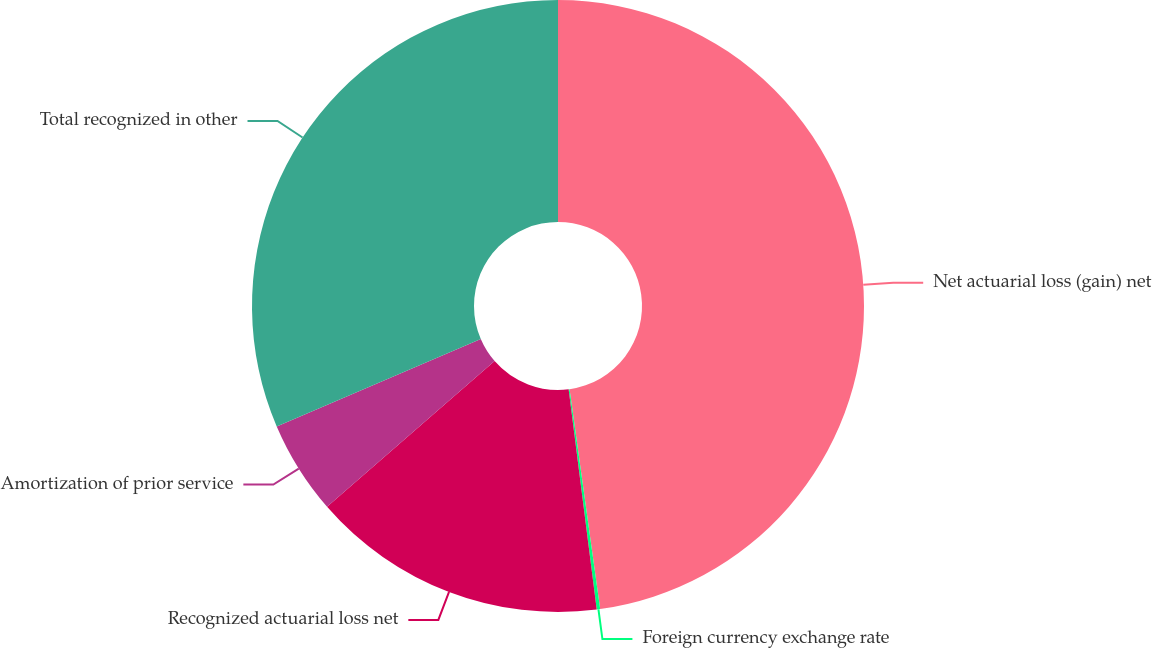<chart> <loc_0><loc_0><loc_500><loc_500><pie_chart><fcel>Net actuarial loss (gain) net<fcel>Foreign currency exchange rate<fcel>Recognized actuarial loss net<fcel>Amortization of prior service<fcel>Total recognized in other<nl><fcel>47.8%<fcel>0.18%<fcel>15.63%<fcel>4.95%<fcel>31.44%<nl></chart> 